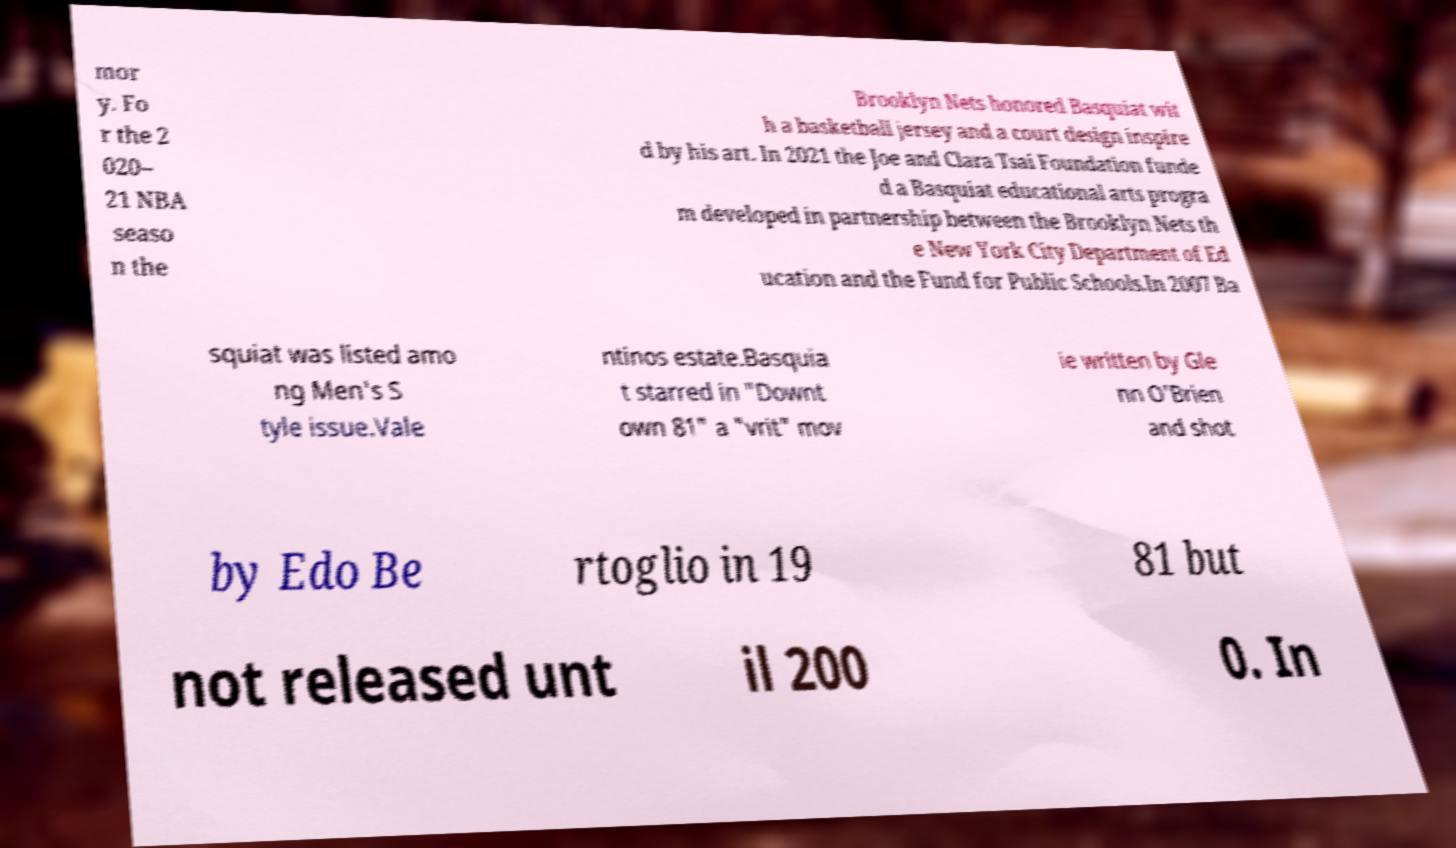What messages or text are displayed in this image? I need them in a readable, typed format. mor y. Fo r the 2 020– 21 NBA seaso n the Brooklyn Nets honored Basquiat wit h a basketball jersey and a court design inspire d by his art. In 2021 the Joe and Clara Tsai Foundation funde d a Basquiat educational arts progra m developed in partnership between the Brooklyn Nets th e New York City Department of Ed ucation and the Fund for Public Schools.In 2007 Ba squiat was listed amo ng Men's S tyle issue.Vale ntinos estate.Basquia t starred in "Downt own 81" a "vrit" mov ie written by Gle nn O'Brien and shot by Edo Be rtoglio in 19 81 but not released unt il 200 0. In 